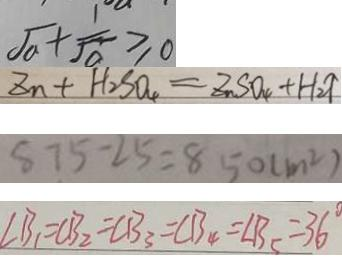Convert formula to latex. <formula><loc_0><loc_0><loc_500><loc_500>\sqrt { a } + \frac { 1 } { \sqrt { a } } \geq 0 
 Z n + H _ { 2 } S O _ { 4 } = Z n S O _ { 4 } + H _ { 2 } \uparrow 
 8 7 5 - 2 5 = 8 5 0 ( m ^ { 2 } ) 
 \angle B _ { 1 } = C B _ { 2 } = C B _ { 3 } = C B _ { 4 } = \angle B _ { 5 } = 3 6 ^ { \circ }</formula> 